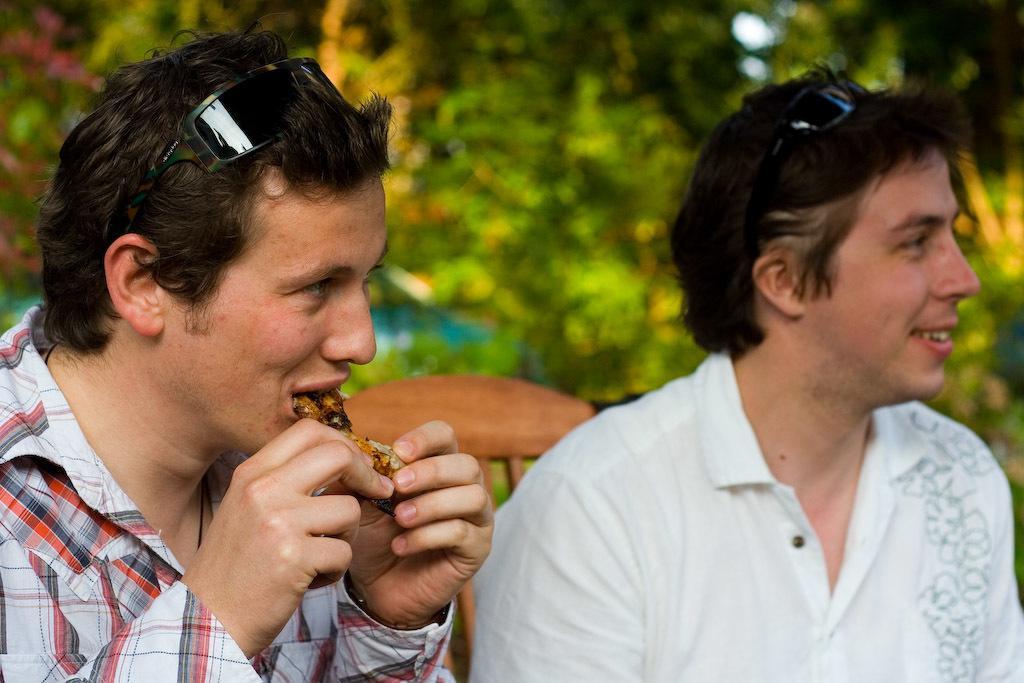How would you summarize this image in a sentence or two? In this image I can see two people sitting on a wooden bench facing towards the right. One person on the left hand side is having food and the background is blurred. 